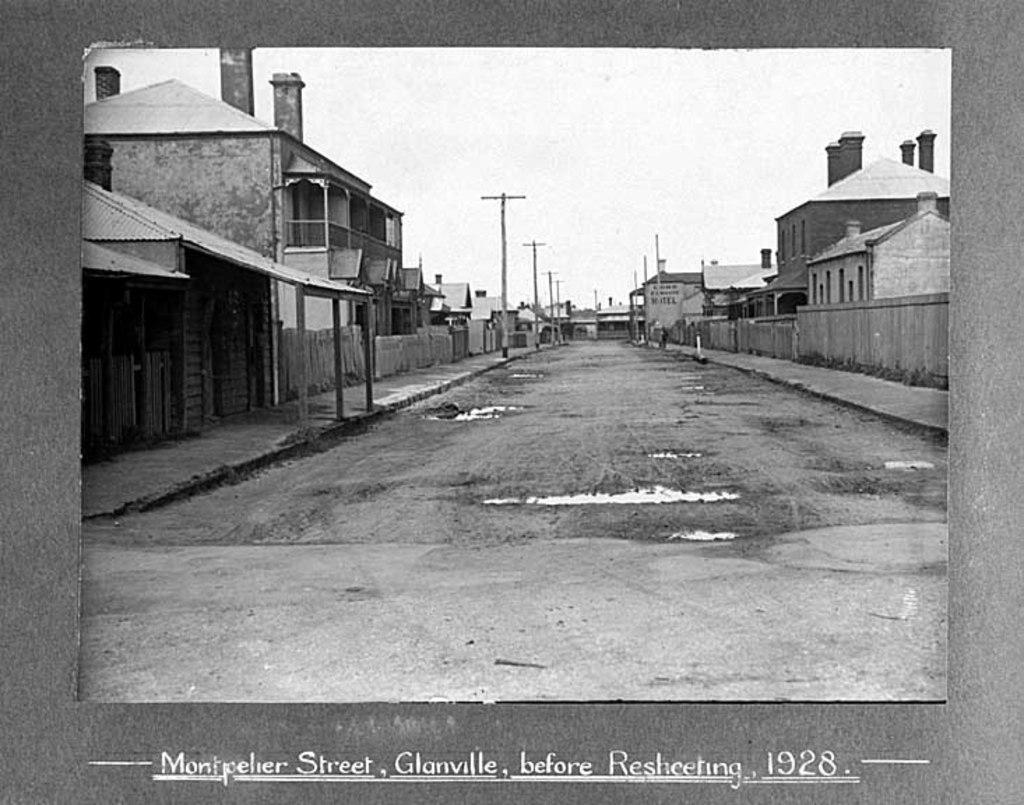What is the color scheme of the image? The image is black and white. What can be seen in the middle of the image? There are buildings and poles in the middle of the image. What is visible at the top of the image? The sky is visible at the top of the image. What type of oatmeal is being served in the image? There is no oatmeal present in the image. Can you see a guitar being played in the image? There is no guitar present in the image. 